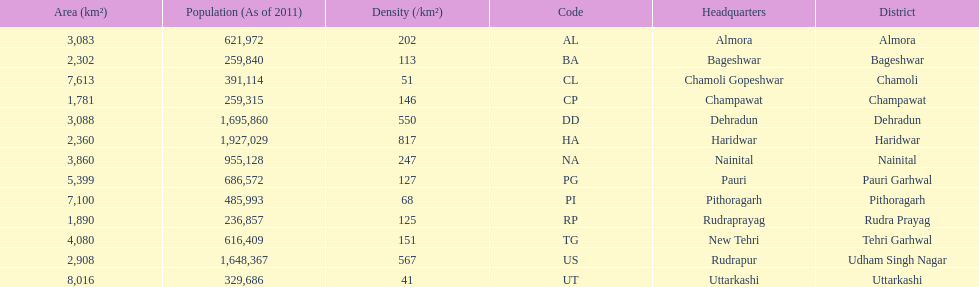How many total districts are there in this area? 13. 